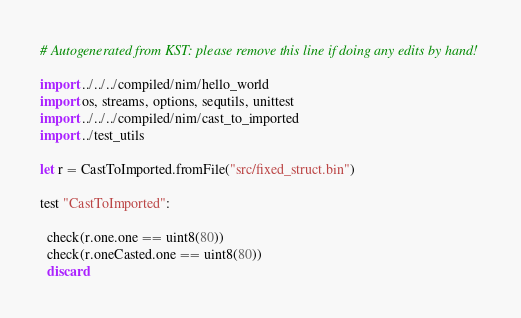Convert code to text. <code><loc_0><loc_0><loc_500><loc_500><_Nim_># Autogenerated from KST: please remove this line if doing any edits by hand!

import ../../../compiled/nim/hello_world
import os, streams, options, sequtils, unittest
import ../../../compiled/nim/cast_to_imported
import ../test_utils

let r = CastToImported.fromFile("src/fixed_struct.bin")

test "CastToImported":

  check(r.one.one == uint8(80))
  check(r.oneCasted.one == uint8(80))
  discard
</code> 